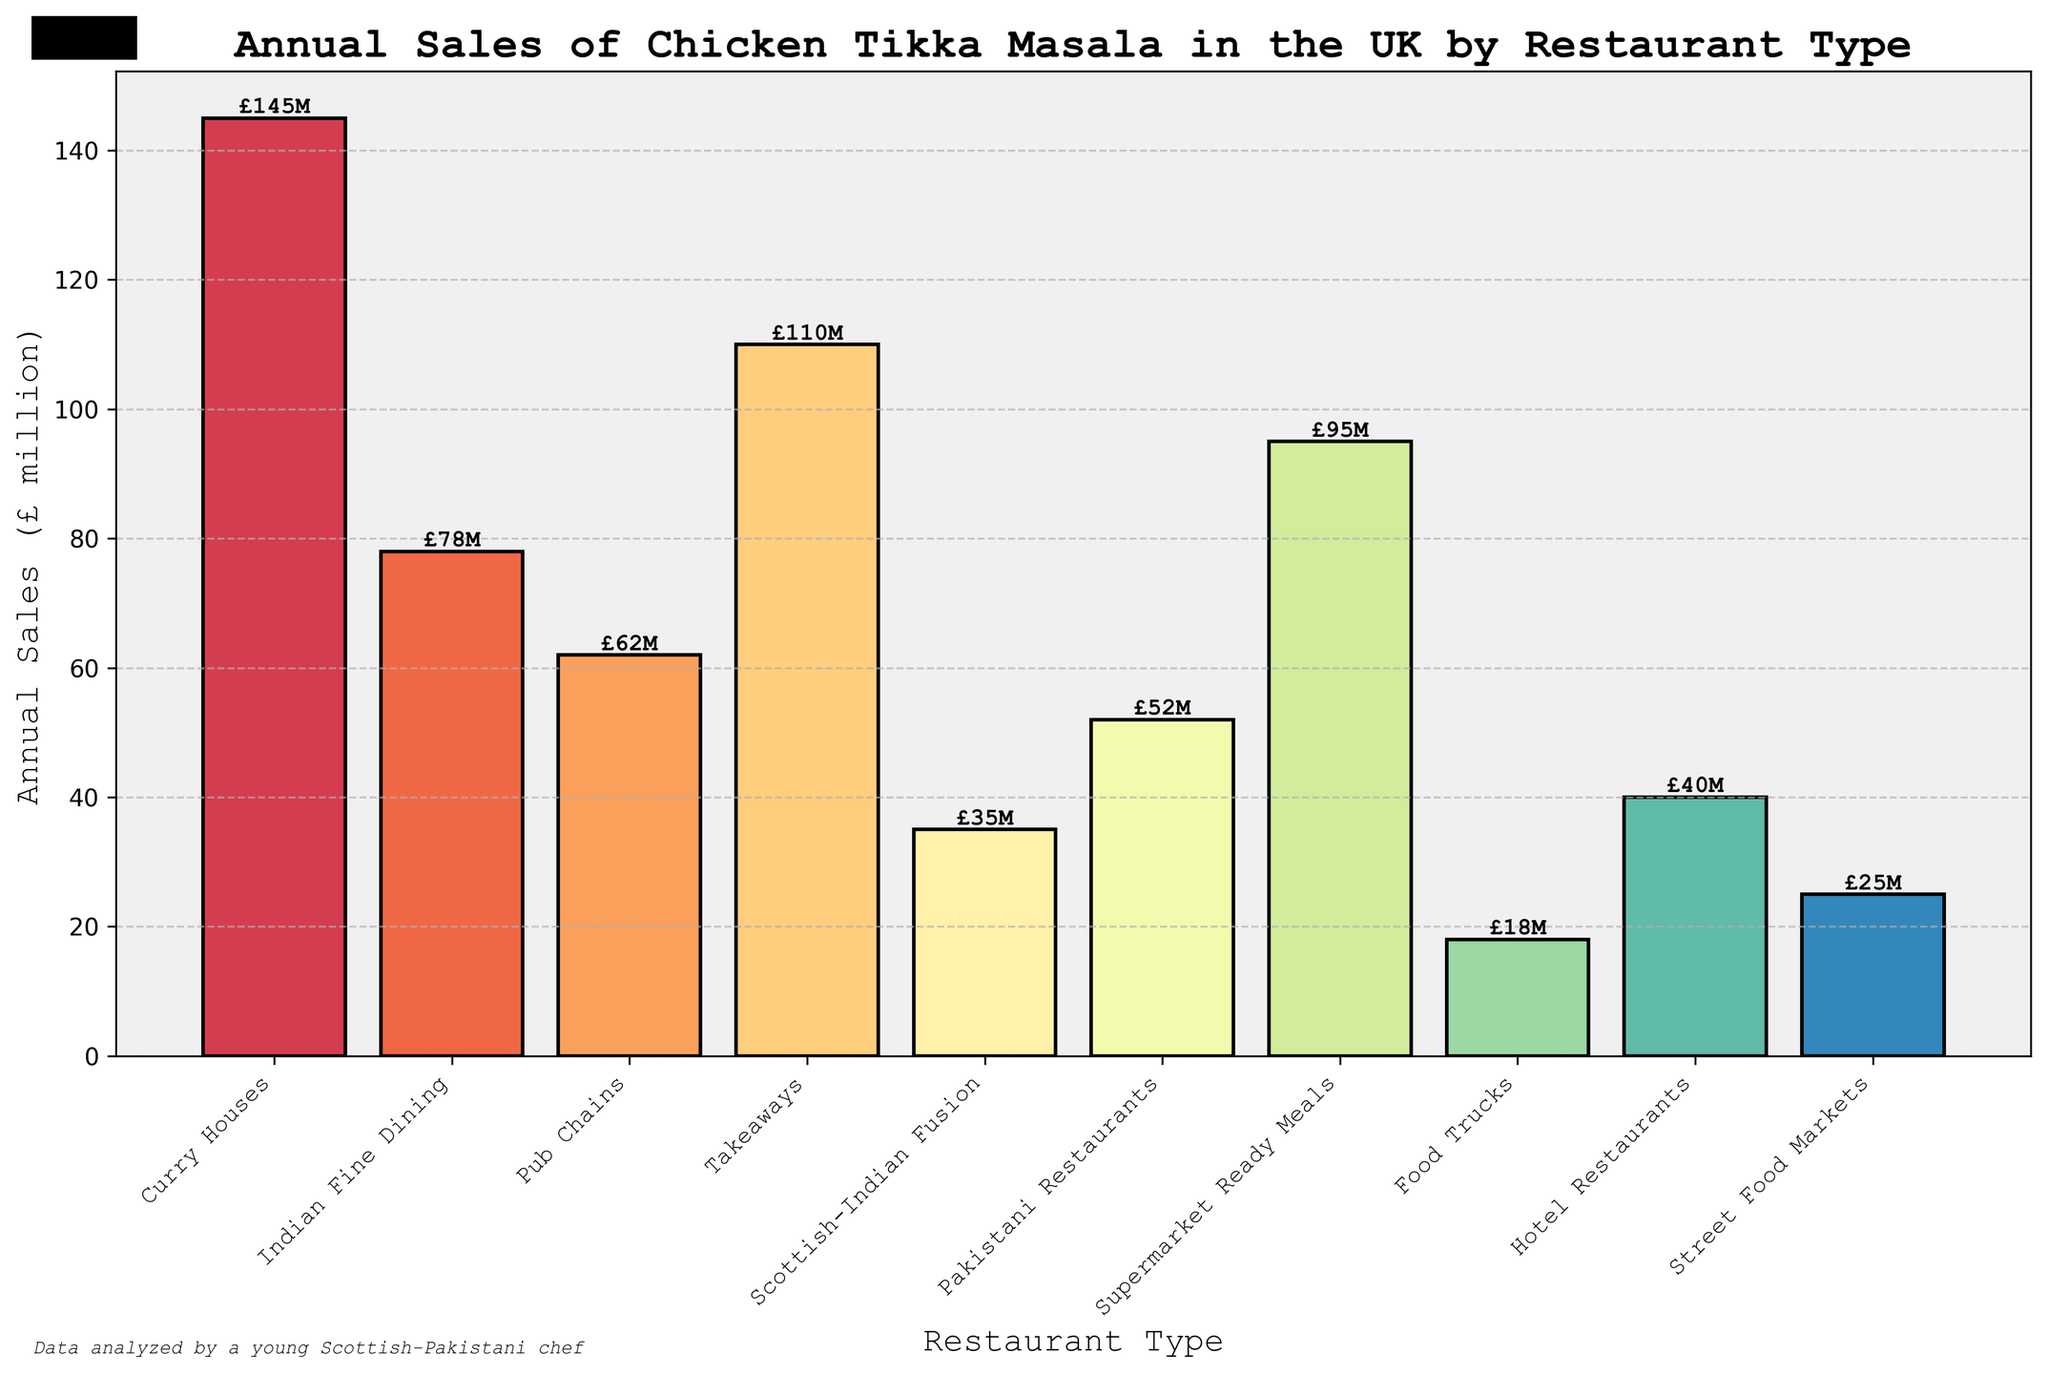Which restaurant type has the highest annual sales of chicken tikka masala? By looking at the height of the bars in the chart, the Curry Houses bar is the tallest, indicating it has the highest annual sales.
Answer: Curry Houses What is the combined annual sales of chicken tikka masala for Curry Houses and Takeaways? Add the sales from Curry Houses (£145 million) and Takeaways (£110 million). So, £145 million + £110 million = £255 million.
Answer: £255 million Which restaurant type has the lowest annual sales of chicken tikka masala? The shortest bar corresponds to Food Trucks, indicating it has the lowest annual sales.
Answer: Food Trucks How much more are the annual sales of Pakistani Restaurants compared to Scottish-Indian Fusion restaurants? Subtract the sales of Scottish-Indian Fusion (£35 million) from Pakistani Restaurants (£52 million). So, £52 million - £35 million = £17 million.
Answer: £17 million Which restaurant type ranks third in annual sales of chicken tikka masala? By comparing the heights of the bars, Takeaways have the third highest sales after Curry Houses and Indian Fine Dining.
Answer: Takeaways What is the average annual sales of chicken tikka masala for Pub Chains, Food Trucks, and Hotel Restaurants? Sum the sales of Pub Chains (£62 million), Food Trucks (£18 million), and Hotel Restaurants (£40 million), then divide by 3. So, (£62 million + £18 million + £40 million) / 3 = £120 million / 3 = £40 million.
Answer: £40 million Between Supermarket Ready Meals and Street Food Markets, which has higher annual sales and by how much? Compare the heights of the bars. Supermarket Ready Meals has higher sales (£95 million) compared to Street Food Markets (£25 million). The difference is £95 million - £25 million = £70 million.
Answer: Supermarket Ready Meals by £70 million Are the annual sales of chicken tikka masala from Curry Houses more than double the sales of Hotel Restaurants? Double the sales of Hotel Restaurants (£40 million * 2 = £80 million). Since Curry Houses sales (£145 million) are more than £80 million, the answer is yes.
Answer: Yes By looking at the visual attributes, which two restaurant types have bars with the most contrasting colors? By examining the colors used in the plot, Curry Houses (a prominent color) and Food Trucks (a much duller color) have the most contrasting colors.
Answer: Curry Houses and Food Trucks 